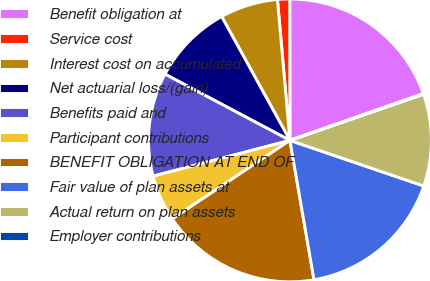Convert chart to OTSL. <chart><loc_0><loc_0><loc_500><loc_500><pie_chart><fcel>Benefit obligation at<fcel>Service cost<fcel>Interest cost on accumulated<fcel>Net actuarial loss/(gain)<fcel>Benefits paid and<fcel>Participant contributions<fcel>BENEFIT OBLIGATION AT END OF<fcel>Fair value of plan assets at<fcel>Actual return on plan assets<fcel>Employer contributions<nl><fcel>19.65%<fcel>1.39%<fcel>6.61%<fcel>9.22%<fcel>11.83%<fcel>5.3%<fcel>18.35%<fcel>17.05%<fcel>10.52%<fcel>0.08%<nl></chart> 